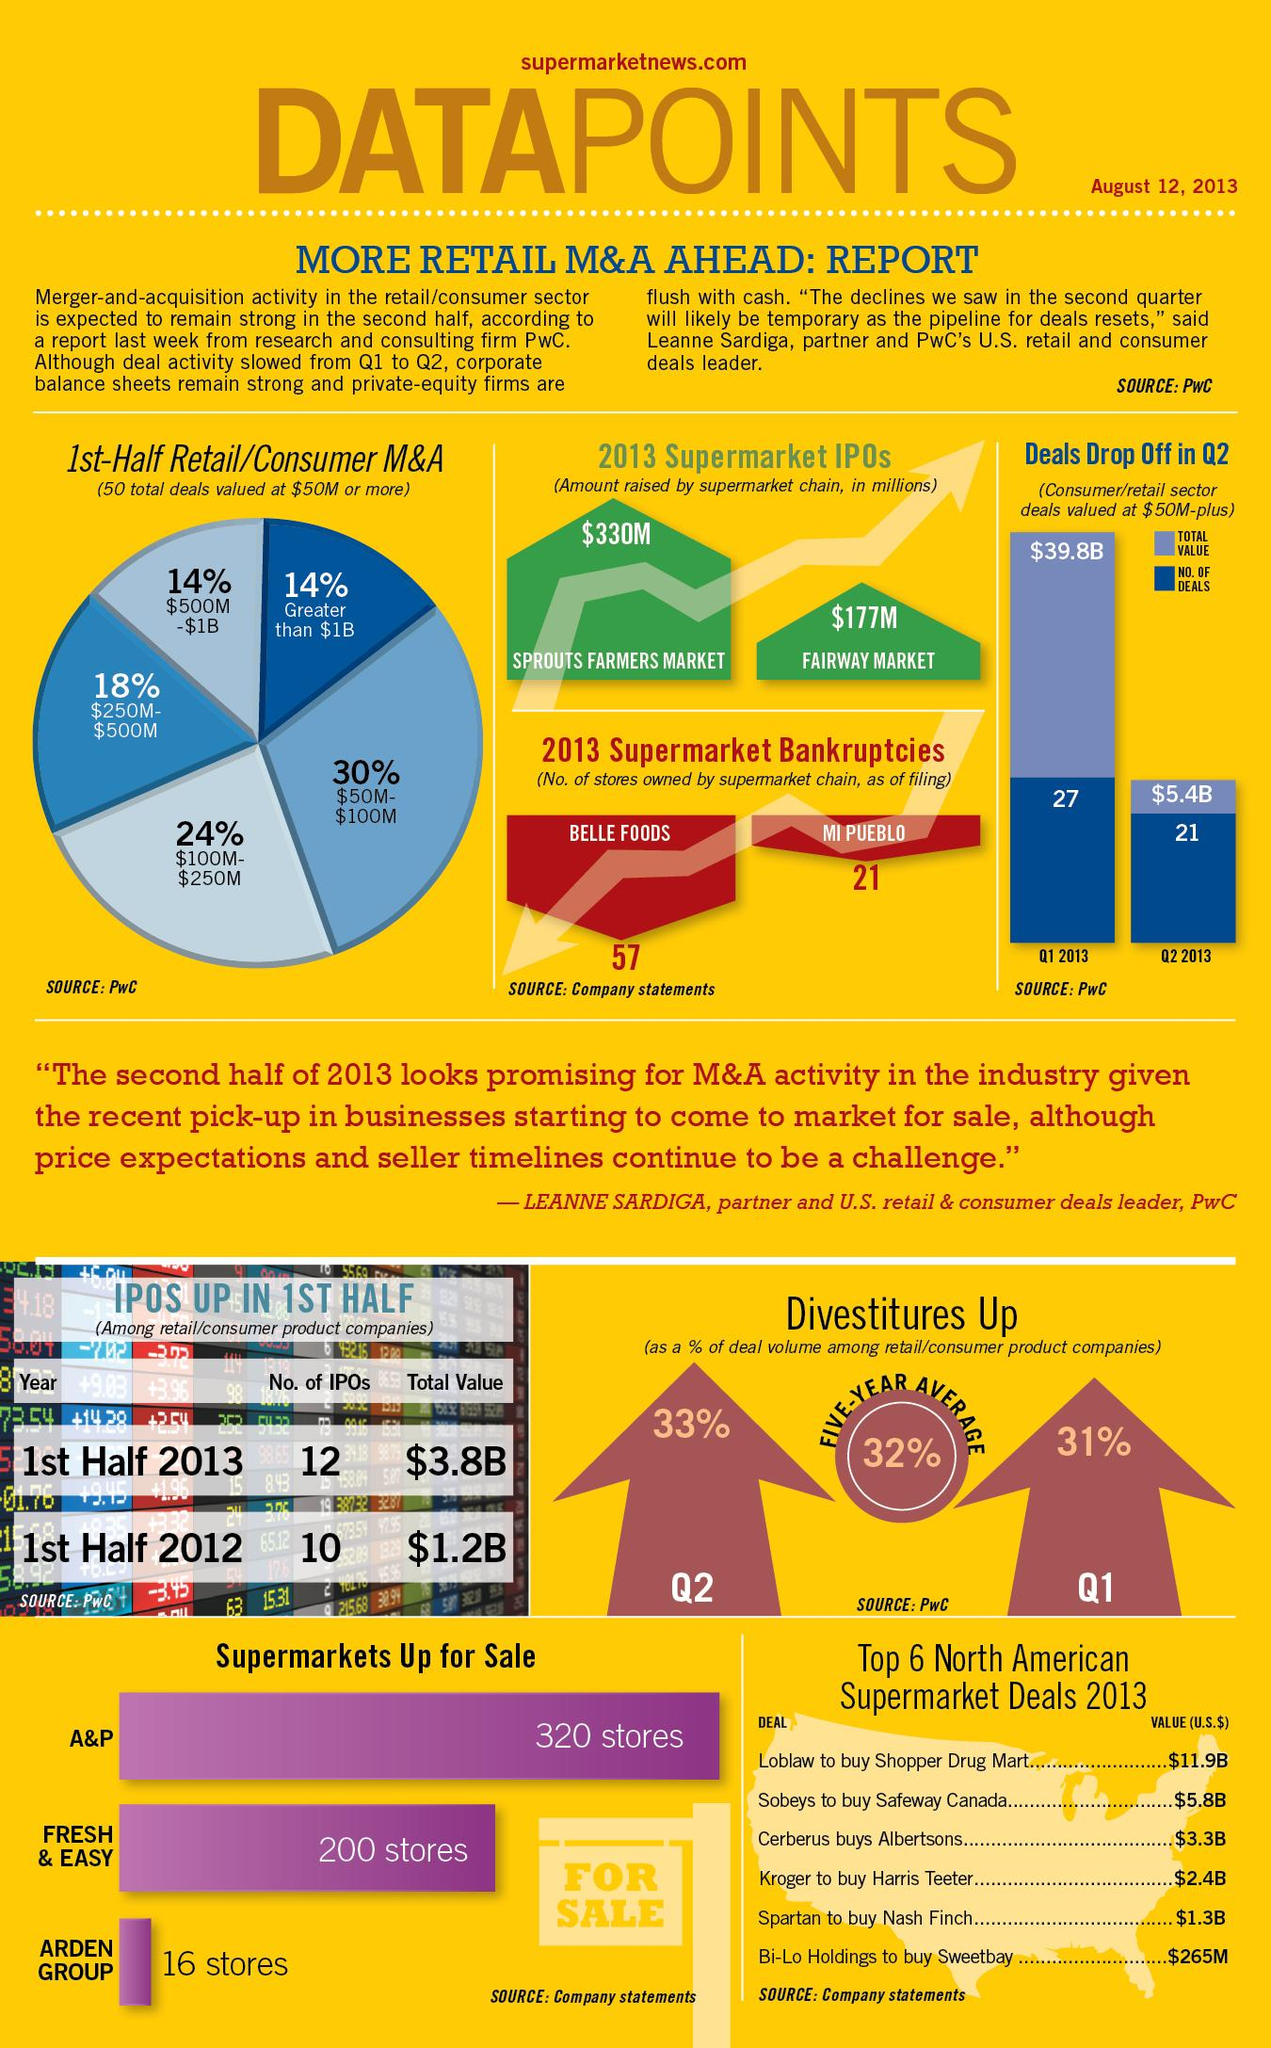Give some essential details in this illustration. In 2013, Bi-Lo Holdings acquired Sweetbay for less than $1 billion, making it the largest supermarket deal in North America. In the first quarter of 2013, the total value of deals was $39.8 billion. In 2013, two supermarkets, Belle Foods and Mi Pueblo, went bankrupt. In North America, several large-scale deals were made above the $6 billion mark, including the acquisition of Shopper Drug Mart by Loblaw. In 2013, Sobeys, a Canadian grocery store chain, acquired Safeway Canada for a total purchase price of $5.8 billion. 